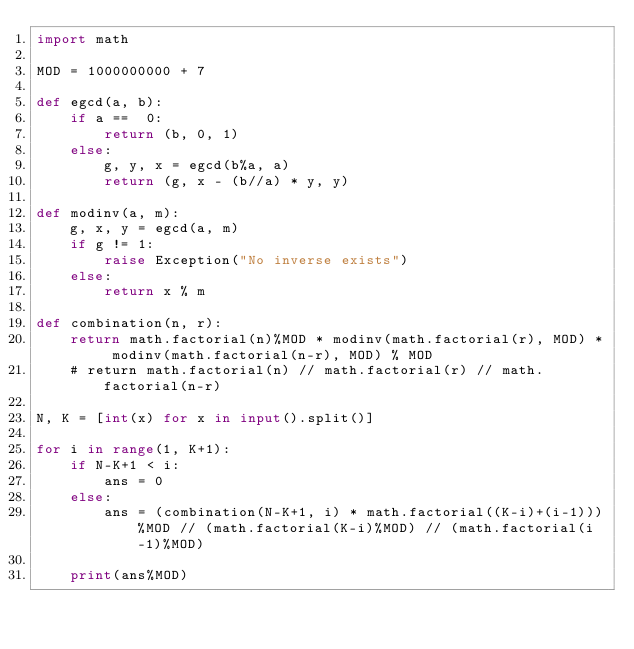<code> <loc_0><loc_0><loc_500><loc_500><_Python_>import math
 
MOD = 1000000000 + 7
 
def egcd(a, b):
    if a ==  0:
        return (b, 0, 1)
    else:
        g, y, x = egcd(b%a, a)
        return (g, x - (b//a) * y, y)
 
def modinv(a, m):
    g, x, y = egcd(a, m)
    if g != 1:
        raise Exception("No inverse exists")
    else:
        return x % m
 
def combination(n, r):
    return math.factorial(n)%MOD * modinv(math.factorial(r), MOD) * modinv(math.factorial(n-r), MOD) % MOD
    # return math.factorial(n) // math.factorial(r) // math.factorial(n-r)
 
N, K = [int(x) for x in input().split()]
 
for i in range(1, K+1):
    if N-K+1 < i:
        ans = 0
    else:
        ans = (combination(N-K+1, i) * math.factorial((K-i)+(i-1)))%MOD // (math.factorial(K-i)%MOD) // (math.factorial(i-1)%MOD)
 
    print(ans%MOD)
</code> 